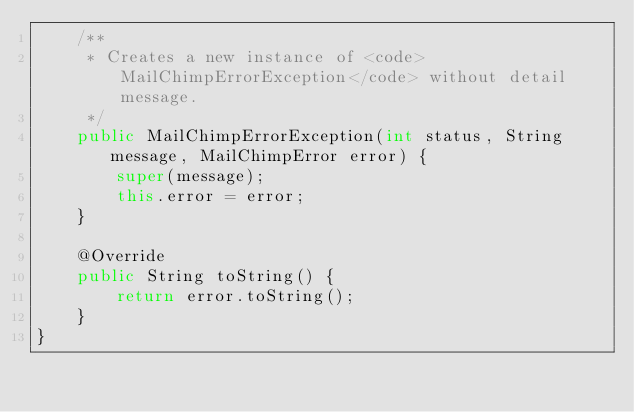<code> <loc_0><loc_0><loc_500><loc_500><_Java_>    /**
     * Creates a new instance of <code>MailChimpErrorException</code> without detail message.
     */
    public MailChimpErrorException(int status, String message, MailChimpError error) {
        super(message);
        this.error = error;
    }

    @Override
    public String toString() {
        return error.toString();
    }
}
</code> 